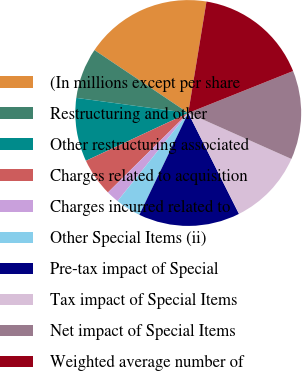Convert chart. <chart><loc_0><loc_0><loc_500><loc_500><pie_chart><fcel>(In millions except per share<fcel>Restructuring and other<fcel>Other restructuring associated<fcel>Charges related to acquisition<fcel>Charges incurred related to<fcel>Other Special Items (ii)<fcel>Pre-tax impact of Special<fcel>Tax impact of Special Items<fcel>Net impact of Special Items<fcel>Weighted average number of<nl><fcel>18.18%<fcel>7.27%<fcel>9.09%<fcel>5.46%<fcel>1.82%<fcel>3.64%<fcel>14.54%<fcel>10.91%<fcel>12.73%<fcel>16.36%<nl></chart> 